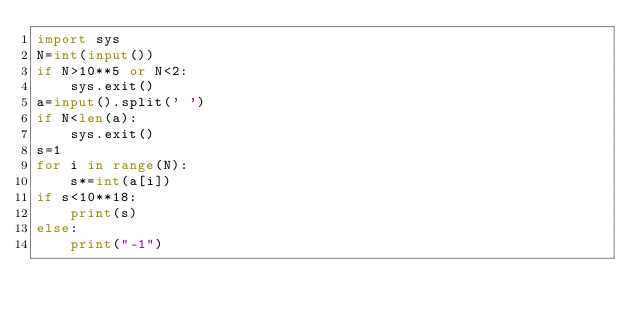<code> <loc_0><loc_0><loc_500><loc_500><_Python_>import sys
N=int(input())
if N>10**5 or N<2:
    sys.exit()
a=input().split(' ')
if N<len(a):
    sys.exit()
s=1
for i in range(N):
    s*=int(a[i])
if s<10**18:
    print(s)
else:
    print("-1")</code> 